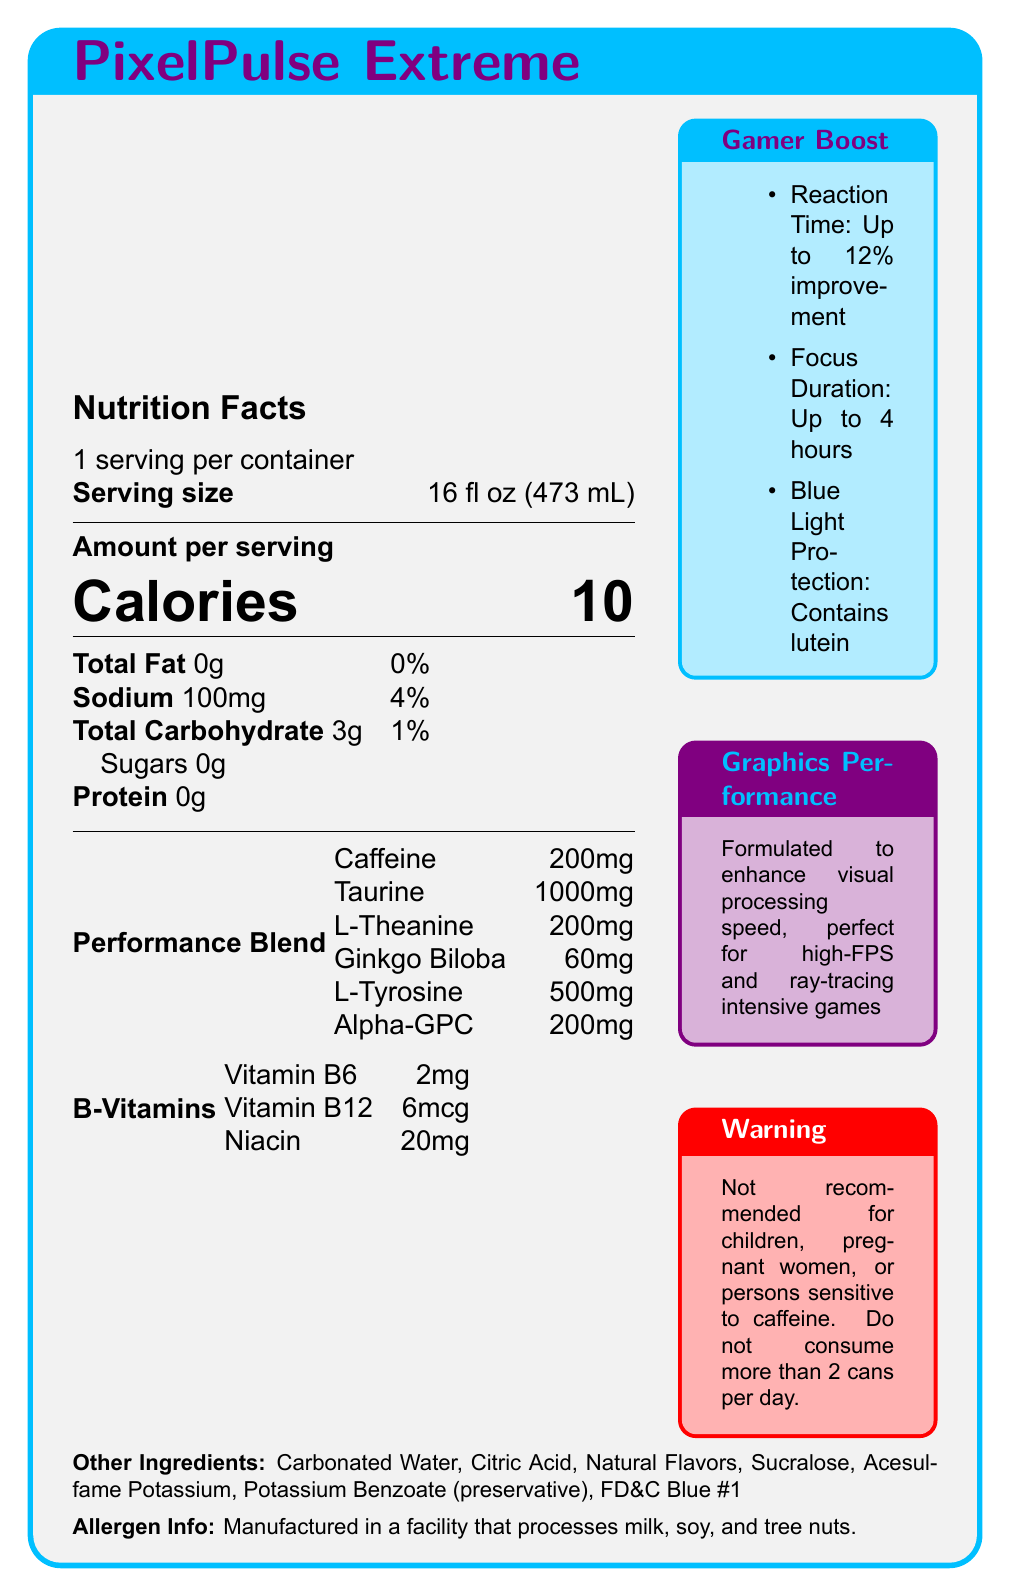what is the serving size of PixelPulse Extreme? The serving size is stated under 'Amount per serving' as "Serving size 16 fl oz (473 mL)".
Answer: 16 fl oz (473 mL) how many calories are in one serving of PixelPulse Extreme? The number of calories is mentioned prominently under 'Amount per serving'.
Answer: 10 calories how much caffeine is included per serving? Caffeine content is listed under the 'Performance Blend' section as "Caffeine 200mg".
Answer: 200mg what is the amount of sodium in a serving of PixelPulse Extreme? The sodium content is listed under 'Total Fat' with the notation "Sodium 100mg".
Answer: 100mg what are the key focus-enhancing ingredients in PixelPulse Extreme? These ingredients are all listed under the 'Performance Blend' section.
Answer: Caffeine, L-Theanine, Taurine, Ginkgo Biloba, L-Tyrosine, Alpha-GPC how many servings are in one container? The servings per container are listed at the top of the document as "1 serving per container".
Answer: 1 what type of vitamins are included in PixelPulse Extreme and in what quantities? A. Vitamin C, Vitamin D, and Vitamin E B. Vitamin A, Vitamin K, and Folic Acid C. Vitamin B6, Vitamin B12, and Niacin D. Riboflavin, Pantothenic Acid, and Biotin The nutrition facts under 'B-Vitamins' list these specific vitamins.
Answer: C. Vitamin B6, Vitamin B12, and Niacin how does PixelPulse Extreme claim to enhance gaming performance? A. Increases physical strength B. Enhances visual processing speed C. Improves digestion D. Increases muscle mass The 'Graphics Performance' section states "Formulated to enhance visual processing speed, perfect for high-FPS and ray-tracing intensive games."
Answer: B. Enhances visual processing speed can children consume PixelPulse Extreme? The 'Warning' section states "Not recommended for children, pregnant women, or persons sensitive to caffeine."
Answer: No describe the overall features and benefits of PixelPulse Extreme as outlined in the document. The explanation is a detailed description of all the key features, contents, and benefits as stated in the document.
Answer: PixelPulse Extreme is a high-performance energy drink designed for gamers, with a serving size of 16 fl oz and containing 10 calories. It includes performance-enhancing ingredients like caffeine (200mg), taurine (1000mg), L-Theanine (200mg), Ginkgo Biloba (60mg), L-Tyrosine (500mg), and Alpha-GPC (200mg), and B-vitamins. It claims to boost gaming performance by improving reaction time and visual processing speed, with added blue light protection for eye health. Warnings are provided for children, pregnant women, and those sensitive to caffeine. what is the main preservative used in PixelPulse Extreme? The list of 'Other Ingredients' includes "Potassium Benzoate (preservative)."
Answer: Potassium Benzoate does PixelPulse Extreme contain any sugar? The 'Total Carbohydrate' section lists Sugars as "0g."
Answer: No is PixelPulse Extreme recommended for people sensitive to caffeine? The 'Warning' section clearly states "Not recommended for children, pregnant women, or persons sensitive to caffeine."
Answer: No where is lutein mentioned in the document, and why is it included? The 'Gamer Boost' section lists "Blue Light Protection: Contains lutein for eye health during long gaming sessions."
Answer: Blue Light Protection contains lutein what is the percentage of daily value for sodium based on a 2000 calorie diet? The percentage of daily value for sodium is listed as 4%.
Answer: 4% which ingredient contributes the highest amount in the performance blend? In the 'Performance Blend', taurine has the highest amount listed as 1000mg.
Answer: Taurine, 1000mg do we know the specific amount of vitamin C in PixelPulse Extreme? The document does not provide information on the content of vitamin C, only specifying B-vitamins.
Answer: Not enough information 